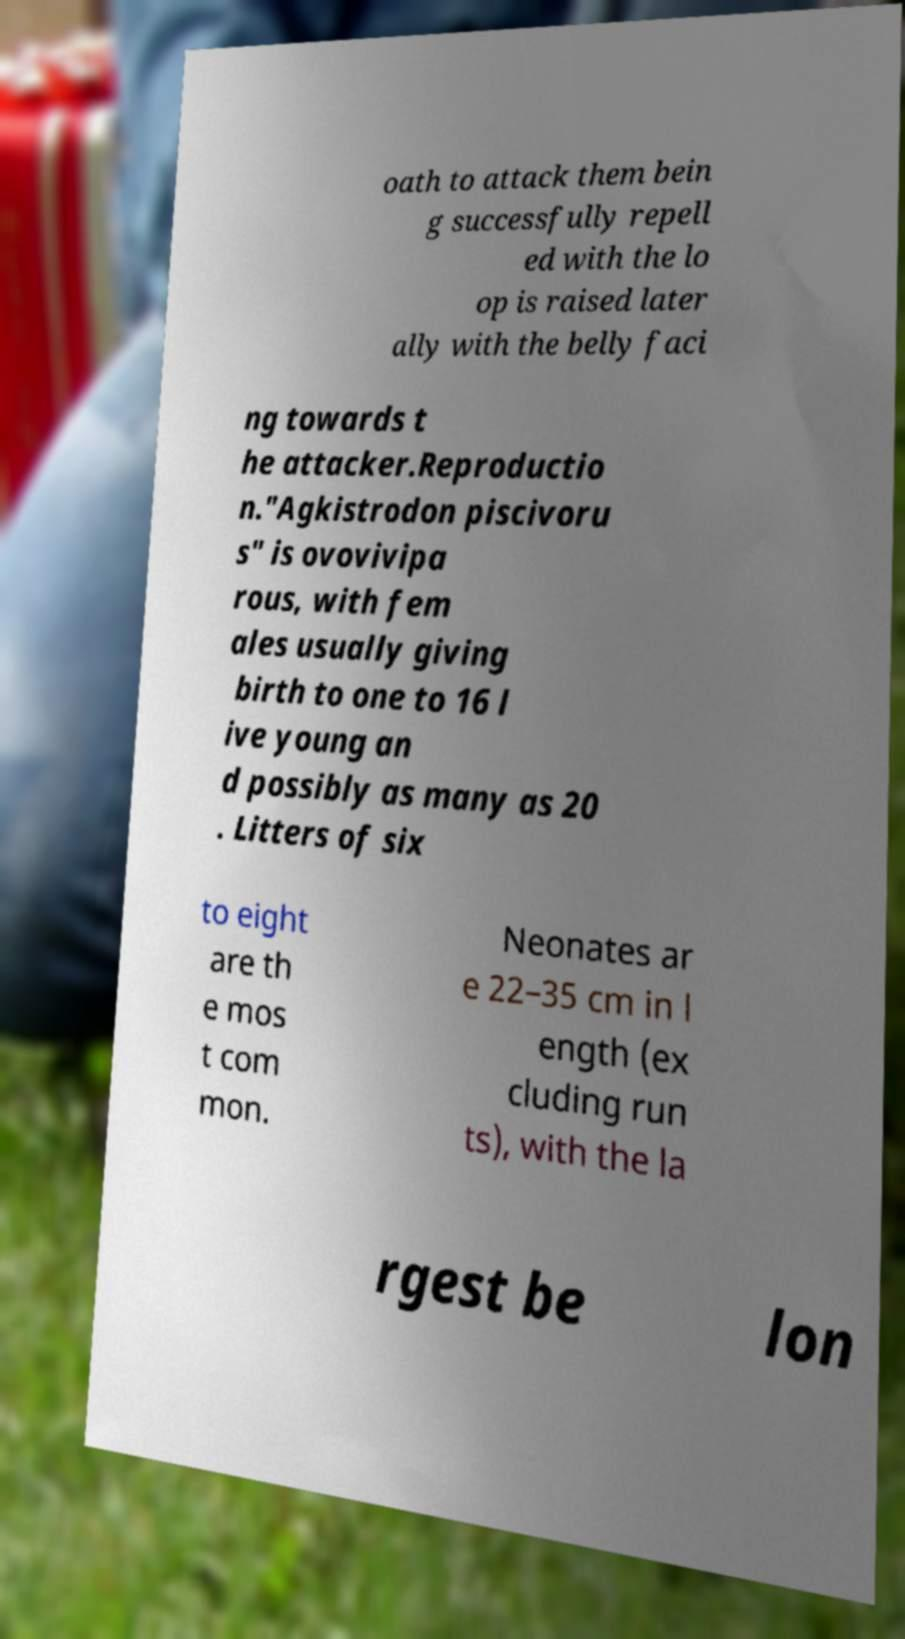I need the written content from this picture converted into text. Can you do that? oath to attack them bein g successfully repell ed with the lo op is raised later ally with the belly faci ng towards t he attacker.Reproductio n."Agkistrodon piscivoru s" is ovovivipa rous, with fem ales usually giving birth to one to 16 l ive young an d possibly as many as 20 . Litters of six to eight are th e mos t com mon. Neonates ar e 22–35 cm in l ength (ex cluding run ts), with the la rgest be lon 